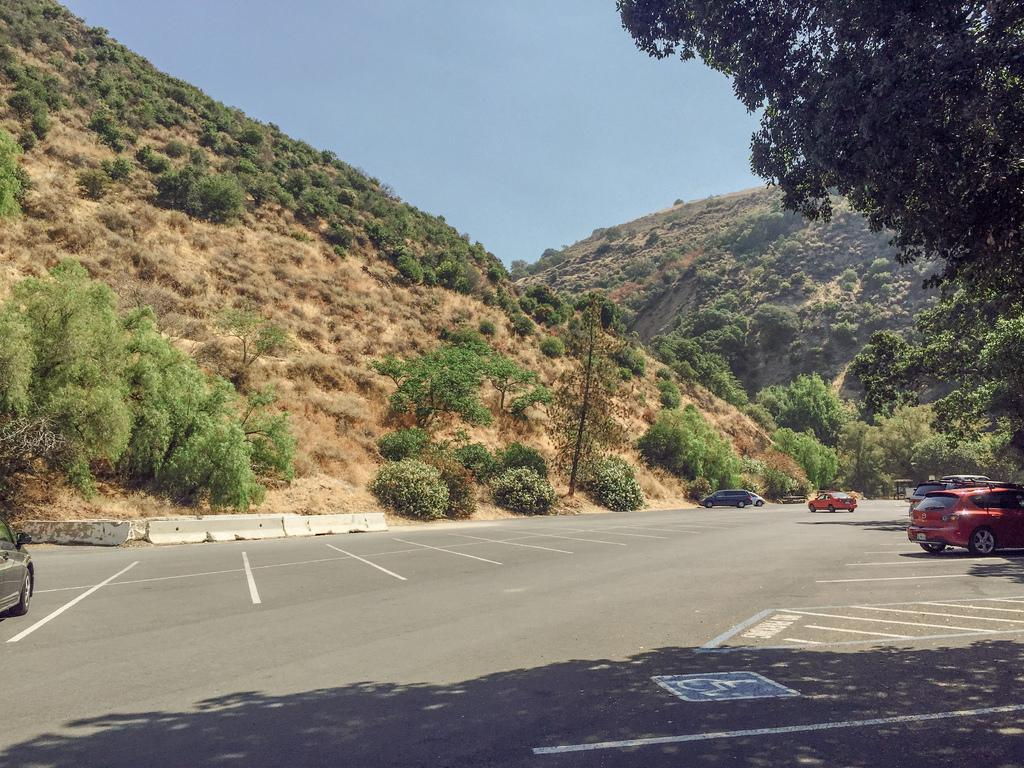What type of vehicles can be seen on the road in the image? There are cars on the road in the image. What can be seen in the background of the image? There are trees and the sky visible in the background of the image. How many frogs are sitting on the wall in the image? There is no wall or frogs present in the image. What type of advice does the governor give to the people in the image? There is no governor or people present in the image, so it is not possible to answer that question. 